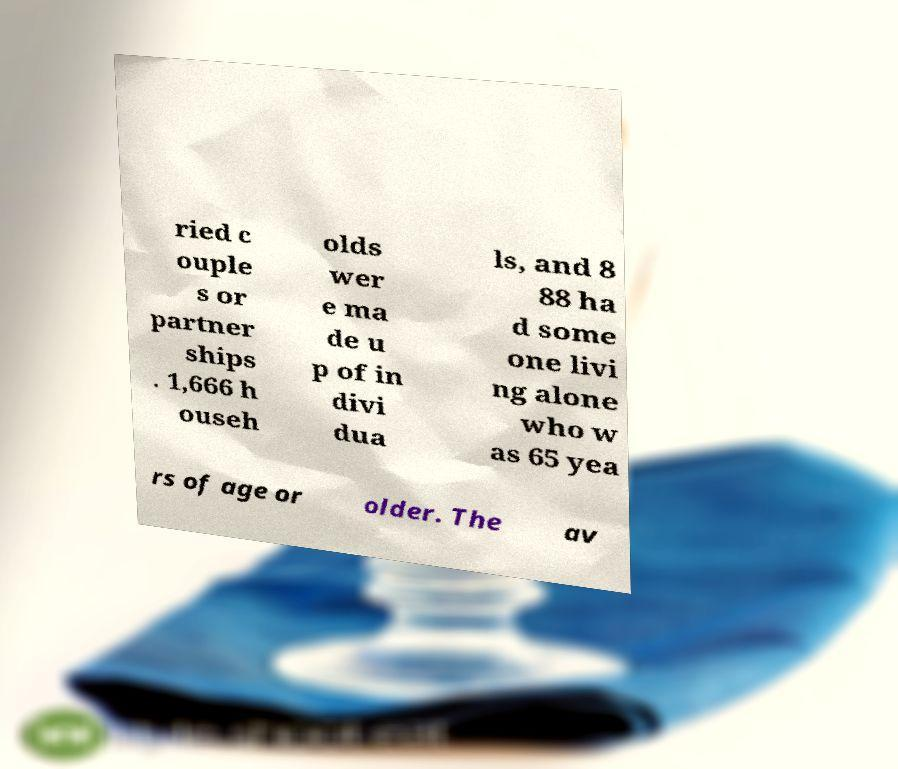Please read and relay the text visible in this image. What does it say? ried c ouple s or partner ships . 1,666 h ouseh olds wer e ma de u p of in divi dua ls, and 8 88 ha d some one livi ng alone who w as 65 yea rs of age or older. The av 